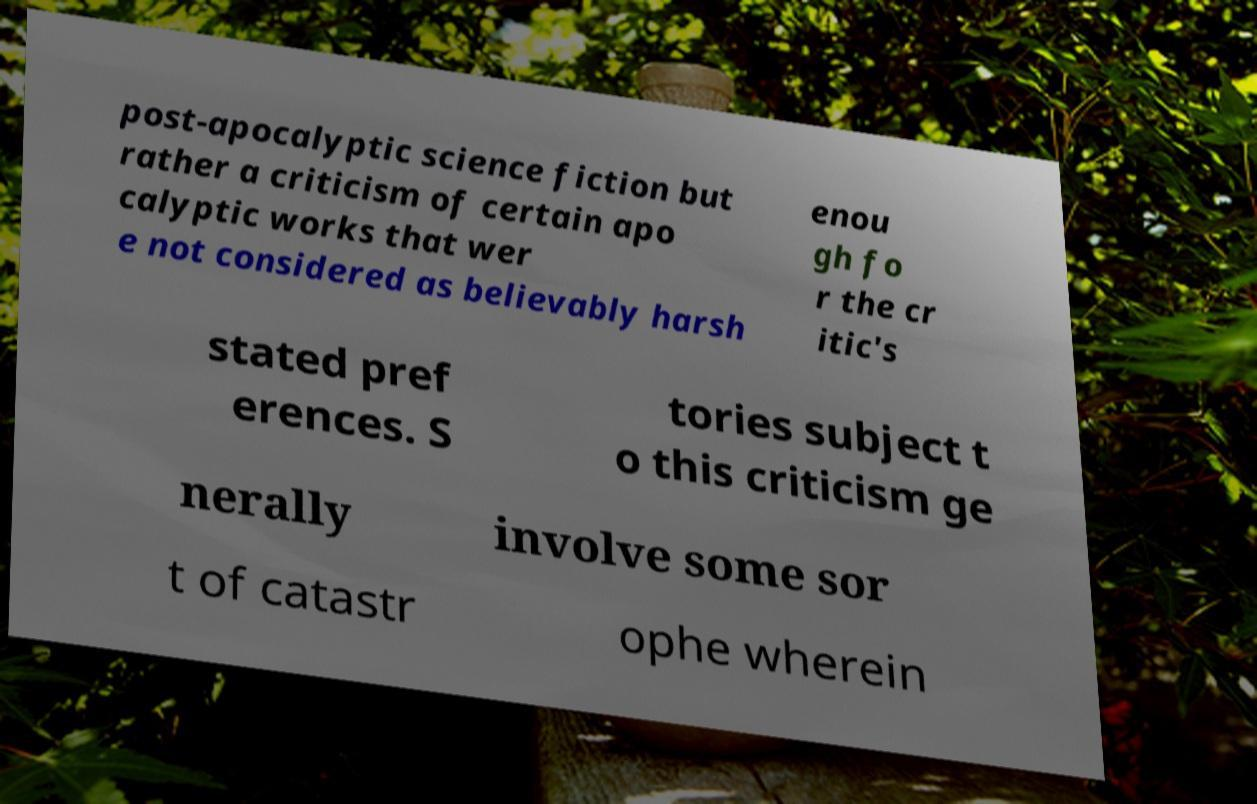There's text embedded in this image that I need extracted. Can you transcribe it verbatim? post-apocalyptic science fiction but rather a criticism of certain apo calyptic works that wer e not considered as believably harsh enou gh fo r the cr itic's stated pref erences. S tories subject t o this criticism ge nerally involve some sor t of catastr ophe wherein 